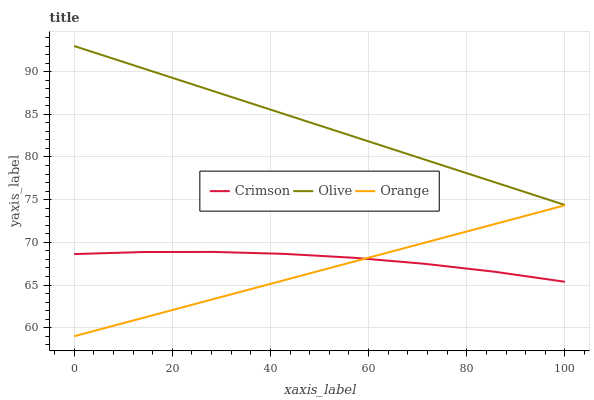Does Olive have the minimum area under the curve?
Answer yes or no. No. Does Orange have the maximum area under the curve?
Answer yes or no. No. Is Olive the smoothest?
Answer yes or no. No. Is Olive the roughest?
Answer yes or no. No. Does Olive have the lowest value?
Answer yes or no. No. Does Orange have the highest value?
Answer yes or no. No. Is Orange less than Olive?
Answer yes or no. Yes. Is Olive greater than Orange?
Answer yes or no. Yes. Does Orange intersect Olive?
Answer yes or no. No. 